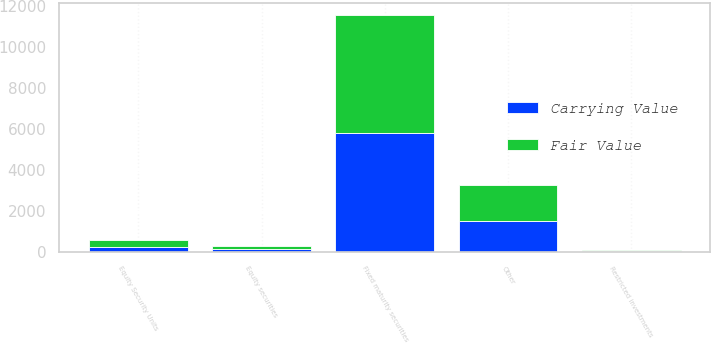Convert chart to OTSL. <chart><loc_0><loc_0><loc_500><loc_500><stacked_bar_chart><ecel><fcel>Fixed maturity securities<fcel>Equity securities<fcel>Restricted investments<fcel>Equity Security Units<fcel>Other<nl><fcel>Carrying Value<fcel>5797.4<fcel>150.7<fcel>48.4<fcel>222.2<fcel>1537.4<nl><fcel>Fair Value<fcel>5797.4<fcel>150.7<fcel>48.4<fcel>357.3<fcel>1727.3<nl></chart> 